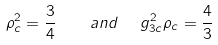Convert formula to latex. <formula><loc_0><loc_0><loc_500><loc_500>\rho _ { c } ^ { 2 } = \frac { 3 } { 4 } \quad a n d \ \ g _ { 3 c } ^ { 2 } \rho _ { c } = \frac { 4 } { 3 }</formula> 